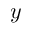<formula> <loc_0><loc_0><loc_500><loc_500>y</formula> 